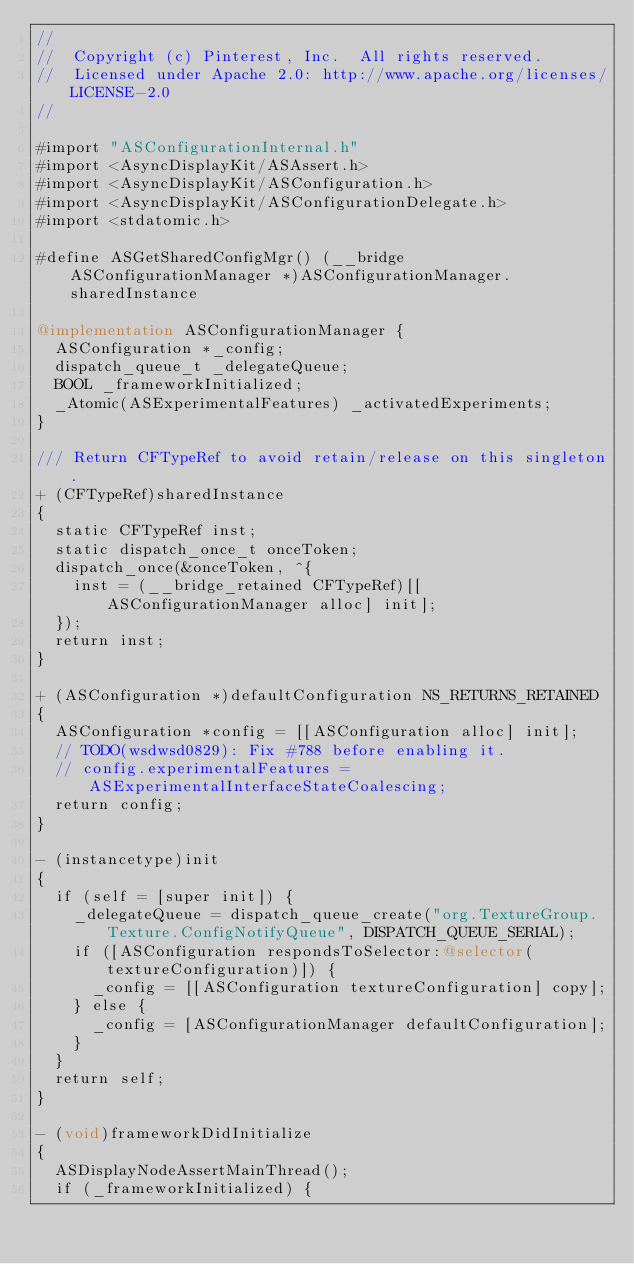<code> <loc_0><loc_0><loc_500><loc_500><_ObjectiveC_>//
//  Copyright (c) Pinterest, Inc.  All rights reserved.
//  Licensed under Apache 2.0: http://www.apache.org/licenses/LICENSE-2.0
//

#import "ASConfigurationInternal.h"
#import <AsyncDisplayKit/ASAssert.h>
#import <AsyncDisplayKit/ASConfiguration.h>
#import <AsyncDisplayKit/ASConfigurationDelegate.h>
#import <stdatomic.h>

#define ASGetSharedConfigMgr() (__bridge ASConfigurationManager *)ASConfigurationManager.sharedInstance

@implementation ASConfigurationManager {
  ASConfiguration *_config;
  dispatch_queue_t _delegateQueue;
  BOOL _frameworkInitialized;
  _Atomic(ASExperimentalFeatures) _activatedExperiments;
}

/// Return CFTypeRef to avoid retain/release on this singleton.
+ (CFTypeRef)sharedInstance
{
  static CFTypeRef inst;
  static dispatch_once_t onceToken;
  dispatch_once(&onceToken, ^{
    inst = (__bridge_retained CFTypeRef)[[ASConfigurationManager alloc] init];
  });
  return inst;
}

+ (ASConfiguration *)defaultConfiguration NS_RETURNS_RETAINED
{
  ASConfiguration *config = [[ASConfiguration alloc] init];
  // TODO(wsdwsd0829): Fix #788 before enabling it.
  // config.experimentalFeatures = ASExperimentalInterfaceStateCoalescing;
  return config;
}

- (instancetype)init
{
  if (self = [super init]) {
    _delegateQueue = dispatch_queue_create("org.TextureGroup.Texture.ConfigNotifyQueue", DISPATCH_QUEUE_SERIAL);
    if ([ASConfiguration respondsToSelector:@selector(textureConfiguration)]) {
      _config = [[ASConfiguration textureConfiguration] copy];
    } else {
      _config = [ASConfigurationManager defaultConfiguration];
    }
  }
  return self;
}

- (void)frameworkDidInitialize
{
  ASDisplayNodeAssertMainThread();
  if (_frameworkInitialized) {</code> 